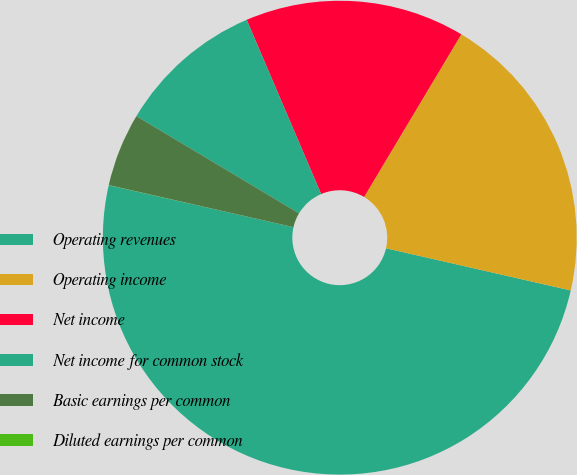Convert chart to OTSL. <chart><loc_0><loc_0><loc_500><loc_500><pie_chart><fcel>Operating revenues<fcel>Operating income<fcel>Net income<fcel>Net income for common stock<fcel>Basic earnings per common<fcel>Diluted earnings per common<nl><fcel>49.98%<fcel>20.0%<fcel>15.0%<fcel>10.0%<fcel>5.01%<fcel>0.01%<nl></chart> 